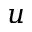Convert formula to latex. <formula><loc_0><loc_0><loc_500><loc_500>u</formula> 